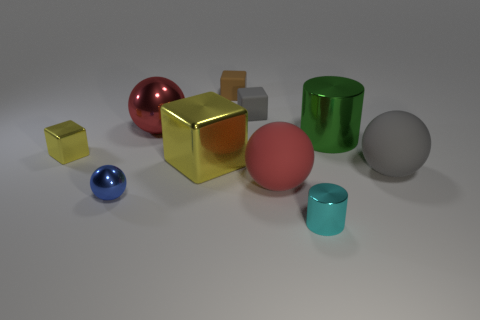Subtract all balls. How many objects are left? 6 Add 10 red metal cubes. How many red metal cubes exist? 10 Subtract 0 purple blocks. How many objects are left? 10 Subtract all blue rubber things. Subtract all red metal things. How many objects are left? 9 Add 7 tiny cyan shiny objects. How many tiny cyan shiny objects are left? 8 